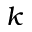Convert formula to latex. <formula><loc_0><loc_0><loc_500><loc_500>k</formula> 